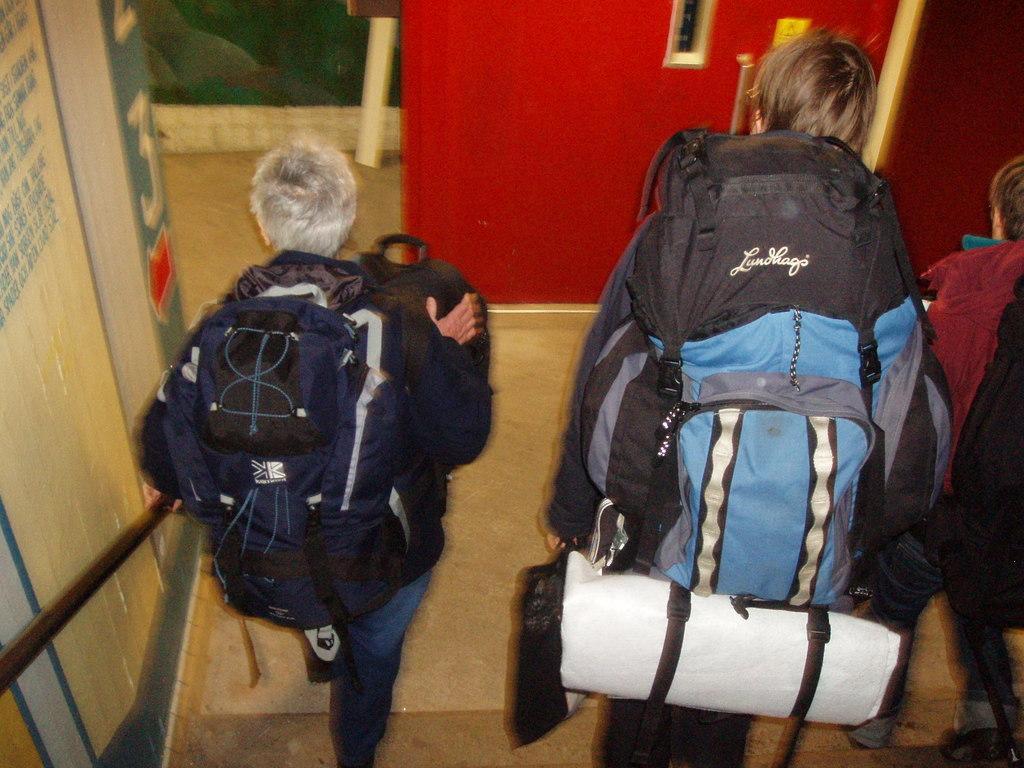In one or two sentences, can you explain what this image depicts? In this image we can see a three persons holding a bag in their hand and they are walking. 